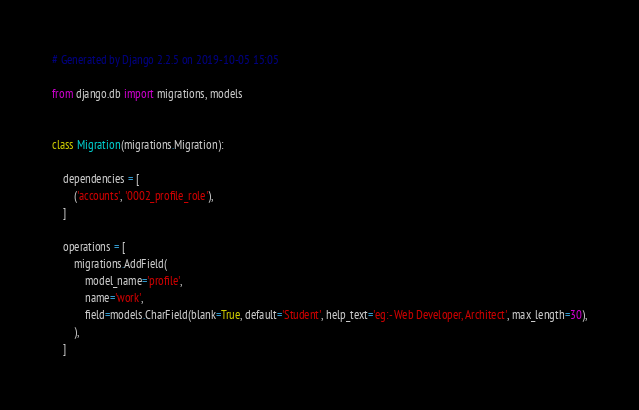<code> <loc_0><loc_0><loc_500><loc_500><_Python_># Generated by Django 2.2.5 on 2019-10-05 15:05

from django.db import migrations, models


class Migration(migrations.Migration):

    dependencies = [
        ('accounts', '0002_profile_role'),
    ]

    operations = [
        migrations.AddField(
            model_name='profile',
            name='work',
            field=models.CharField(blank=True, default='Student', help_text='eg:- Web Developer, Architect', max_length=30),
        ),
    ]
</code> 